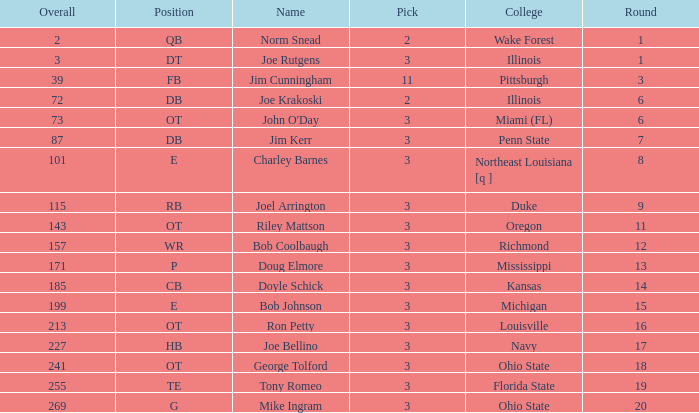How many overalls have charley barnes as the name, with a pick less than 3? None. 